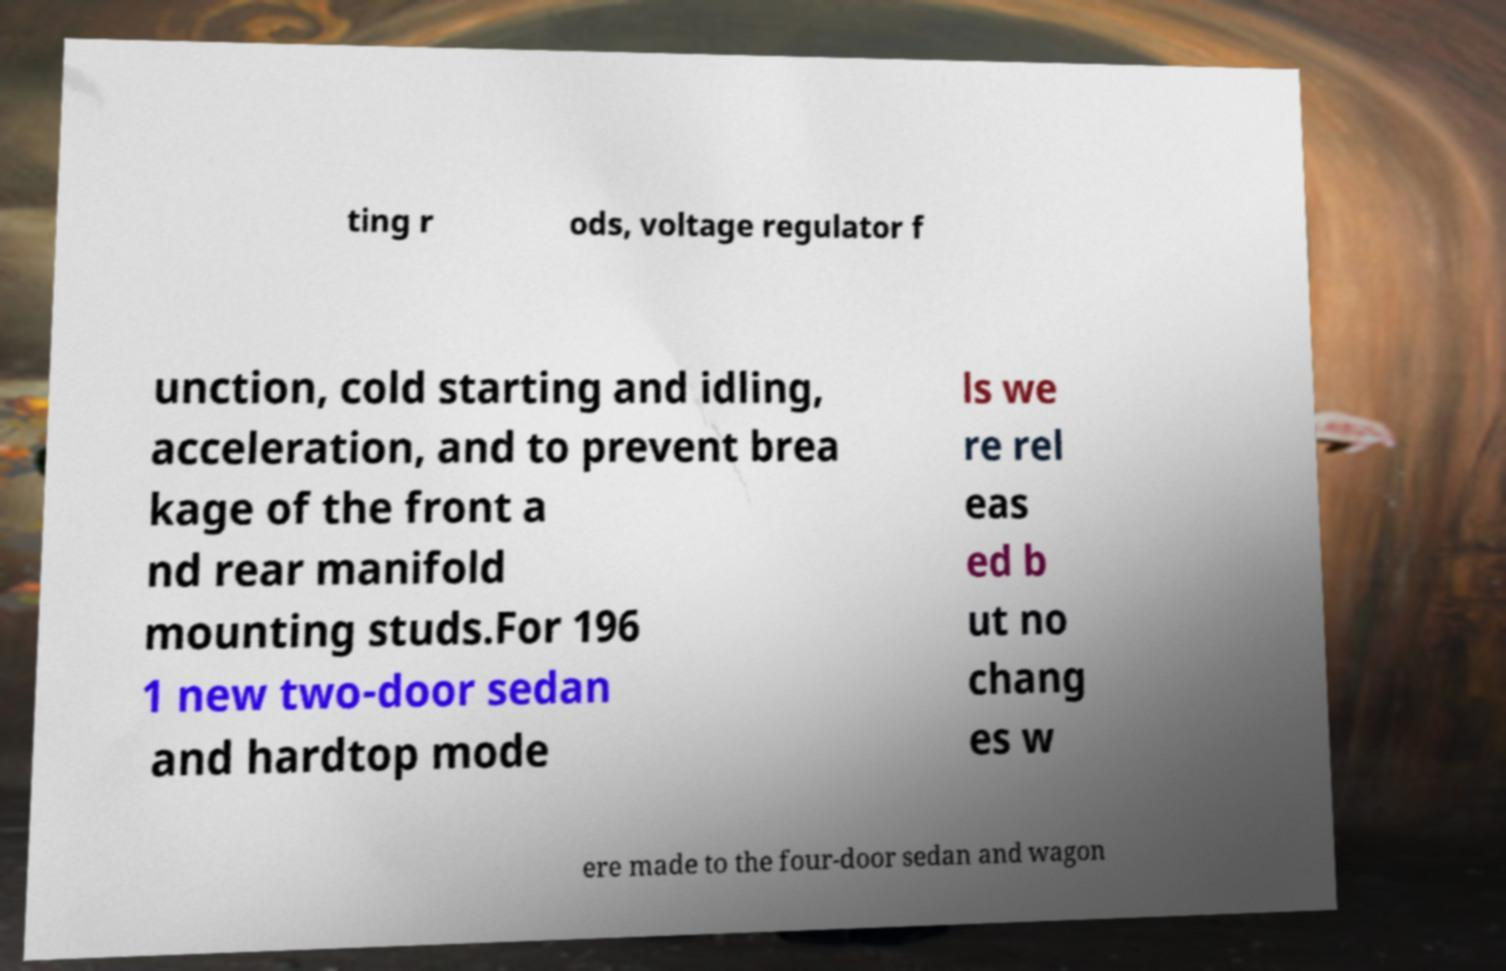There's text embedded in this image that I need extracted. Can you transcribe it verbatim? ting r ods, voltage regulator f unction, cold starting and idling, acceleration, and to prevent brea kage of the front a nd rear manifold mounting studs.For 196 1 new two-door sedan and hardtop mode ls we re rel eas ed b ut no chang es w ere made to the four-door sedan and wagon 